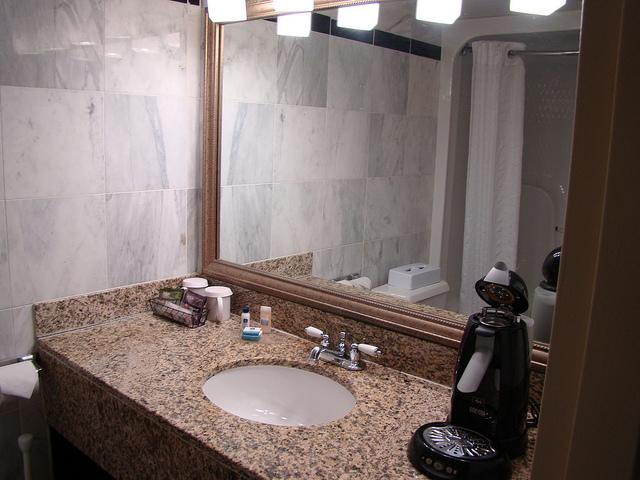Who folded the toilet paper roll into a point to the left of the sink? Please explain your reasoning. cleaning staff. The cleaning staff folded the toilet paper roll to make it look presentable. 